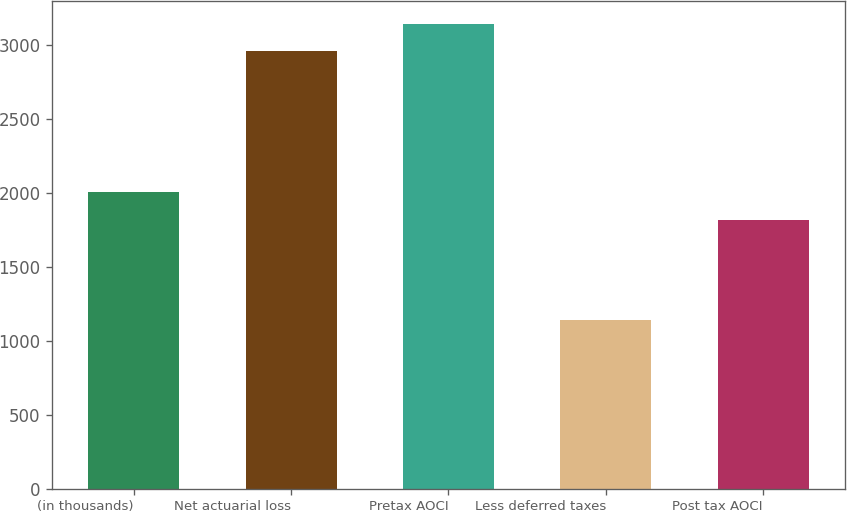Convert chart to OTSL. <chart><loc_0><loc_0><loc_500><loc_500><bar_chart><fcel>(in thousands)<fcel>Net actuarial loss<fcel>Pretax AOCI<fcel>Less deferred taxes<fcel>Post tax AOCI<nl><fcel>2008<fcel>2958<fcel>3139.6<fcel>1142<fcel>1816<nl></chart> 